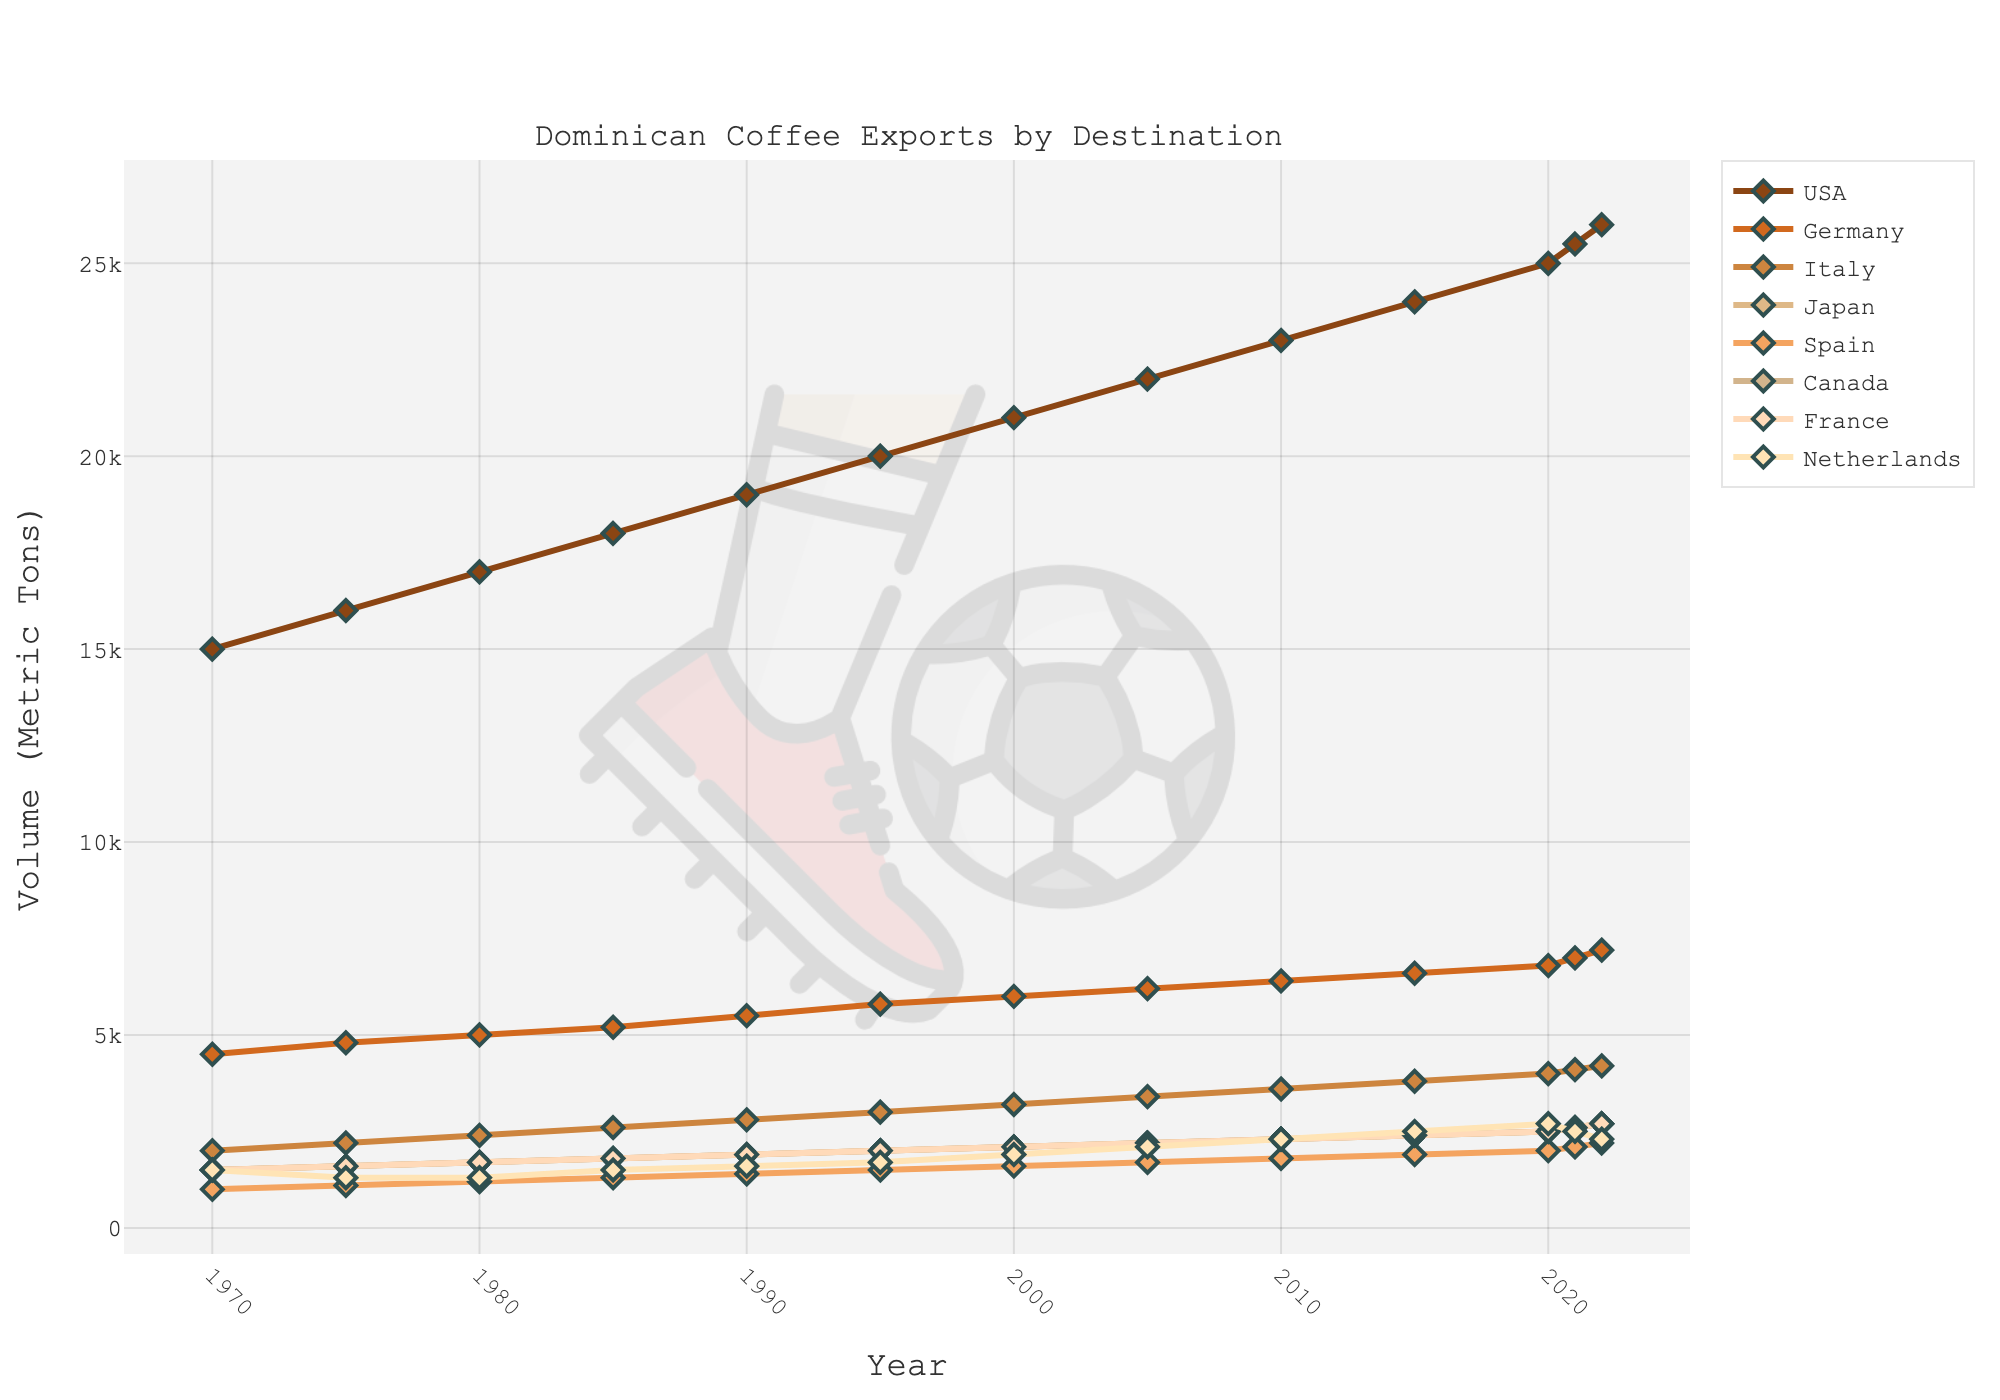How many metric tons of Dominican coffee were exported to the USA and Germany combined in 2000? To find the combined volume of coffee exported to the USA and Germany in 2000, locate the respective data points on the figure. For 2000, the USA received 21,000 metric tons, and Germany received 6,000 metric tons. Add these values: 21,000 + 6,000 = 27,000.
Answer: 27,000 Which country had the highest increase in coffee exports from 1970 to 2022? To determine the country with the highest increase, calculate the difference in export volume between 1970 and 2022 for each country by subtracting the 1970 values from the 2022 values. The country with the largest positive difference is the answer. The USA increased from 15,000 to 26,000 (11,000 increase), Germany from 4,500 to 7,200 (2,700 increase), Italy from 2,000 to 4,200 (2,200 increase), Japan from 1,500 to 2,700 (1,200 increase), Spain from 1,000 to 2,200 (1,200 increase), Canada from 1,500 to 2,700 (1,200 increase), France from 1,500 to 2,700 (1,200 increase), and Netherlands from 1,500 to 2,300 (800 increase). The USA has the highest increase.
Answer: USA Which country's export volume remained constant the longest, and for how many years? Identify the country whose export line remains unchanged for the longest period on the graph. For each country, visually trace the duration where the export volume doesn't change. For example, if the line for Spain stays flat between multiple years, count these years. Spain shows the longest constant volume from 1975 to 1985, which is 10 years.
Answer: Spain, 10 What is the total export volume to Italy across all years shown? Sum the export volumes to Italy for each year from 1970 to 2022. The values are 2,000, 2,200, 2,400, 2,600, 2,800, 3,000, 3,200, 3,400, 3,600, 3,800, 4,000, 4,100, and 4,200. Adding these together: 2,000 + 2,200 + 2,400 + 2,600 + 2,800 + 3,000 + 3,200 + 3,400 + 3,600 + 3,800 + 4,000 + 4,100 + 4,200 = 41,300 metric tons.
Answer: 41,300 In which year did Canada’s coffee imports surpass France's for the first time? Examine the plotted lines for Canada and France and look for the point where the Canadian line crosses above the French line for the first time. This crossing occurs in 2020, where Canada's exports (2,500 metric tons) surpass France's (2,500 metric tons, which is equal and then Canada surpasses).
Answer: 2020 Which country showed the least fluctuation in coffee export volume over the entire period? Look for the country whose export volume line is the least variable (most stable) from 1970 to 2022. Calculate the standard deviation for each country's export volume to measure this quantitatively. A visual inspection suggests that Japan shows minimal fluctuation compared to others, as its line is relatively smooth.
Answer: Japan What is the average annual export volume of coffee to Germany from 1990 to 2022? Find the average of Germany's export volumes from 1990 to 2022 by adding these values and dividing by the number of years. The values are 5,500, 5,800, 6,000, 6,200, 6,400, 6,600, 6,800, 7,000, 7,200. The sum is 60,700, divided by 9 gives an average of 6,744 metric tons.
Answer: 6,744 What year had the highest total volume of coffee exports, and what was the total volume? Sum up the export volumes across all countries for each year and identify the year with the highest total. By adding the export volumes for 2022: 26,000 (USA) + 7,200 (Germany) + 4,200 (Italy) + 2,700 (Japan) + 2,200 (Spain) + 2,700 (Canada) + 2,700 (France) + 2,300 (Netherlands) = 50,000 metric tons, which is the highest.
Answer: 2022, 50,000 